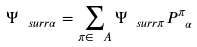Convert formula to latex. <formula><loc_0><loc_0><loc_500><loc_500>\Psi _ { \ s u r r { \alpha } } = \sum _ { \pi \in \ A } \Psi _ { \ s u r r { \pi } } P ^ { \pi } _ { \ \alpha }</formula> 